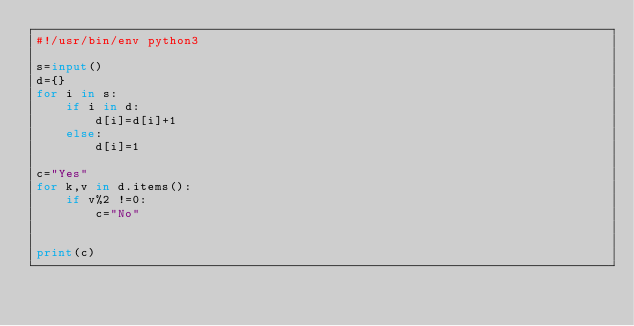Convert code to text. <code><loc_0><loc_0><loc_500><loc_500><_Python_>#!/usr/bin/env python3

s=input()
d={}
for i in s:
    if i in d:
        d[i]=d[i]+1
    else:
        d[i]=1

c="Yes"
for k,v in d.items():
    if v%2 !=0:
        c="No"


print(c)
</code> 